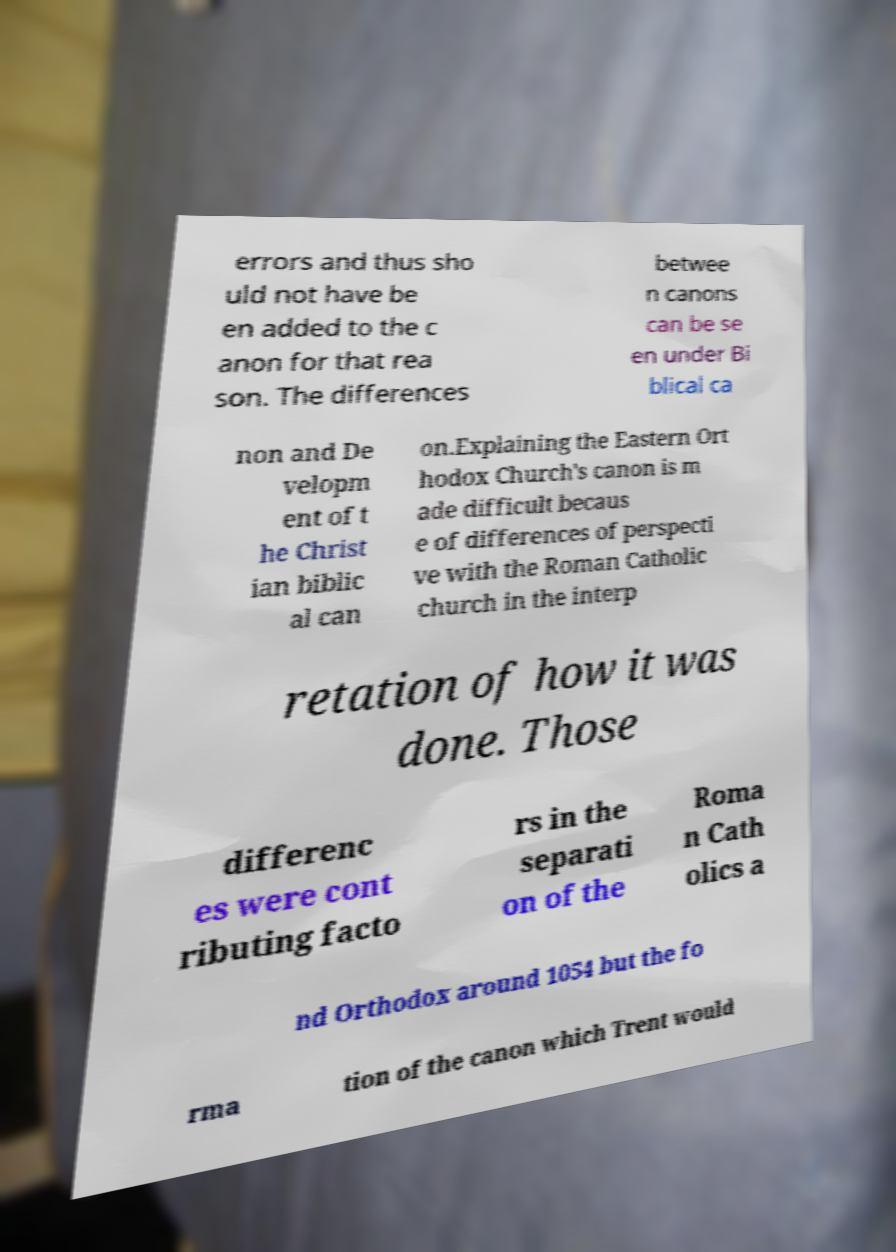Please identify and transcribe the text found in this image. errors and thus sho uld not have be en added to the c anon for that rea son. The differences betwee n canons can be se en under Bi blical ca non and De velopm ent of t he Christ ian biblic al can on.Explaining the Eastern Ort hodox Church's canon is m ade difficult becaus e of differences of perspecti ve with the Roman Catholic church in the interp retation of how it was done. Those differenc es were cont ributing facto rs in the separati on of the Roma n Cath olics a nd Orthodox around 1054 but the fo rma tion of the canon which Trent would 